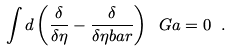<formula> <loc_0><loc_0><loc_500><loc_500>\int d \left ( \frac { \delta } { \delta \eta } - \frac { \delta } { \delta \eta b a r } \right ) \ G a = 0 \ .</formula> 